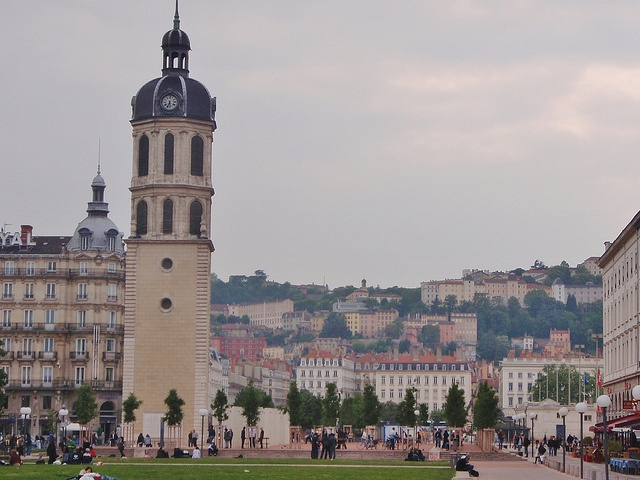Describe the objects in this image and their specific colors. I can see people in darkgray, black, and gray tones, clock in darkgray, gray, and black tones, people in darkgray, black, darkgreen, and gray tones, people in darkgray, black, maroon, and gray tones, and people in darkgray, black, and gray tones in this image. 